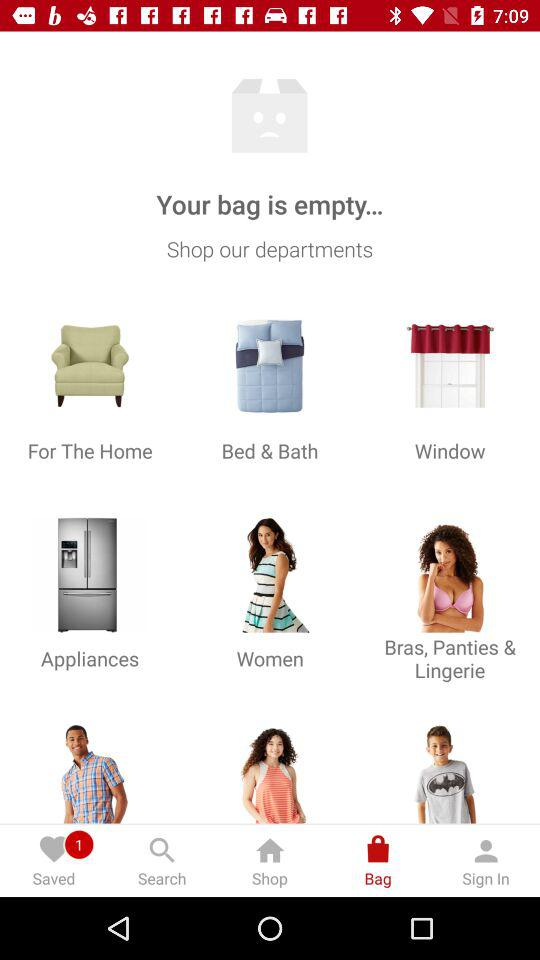Is there any item in the bag?
When the provided information is insufficient, respond with <no answer>. <no answer> 